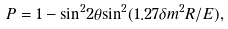Convert formula to latex. <formula><loc_0><loc_0><loc_500><loc_500>P = 1 - { \sin } ^ { 2 } 2 { \theta } { \sin } ^ { 2 } ( 1 . 2 7 { \delta } m ^ { 2 } R / E ) ,</formula> 